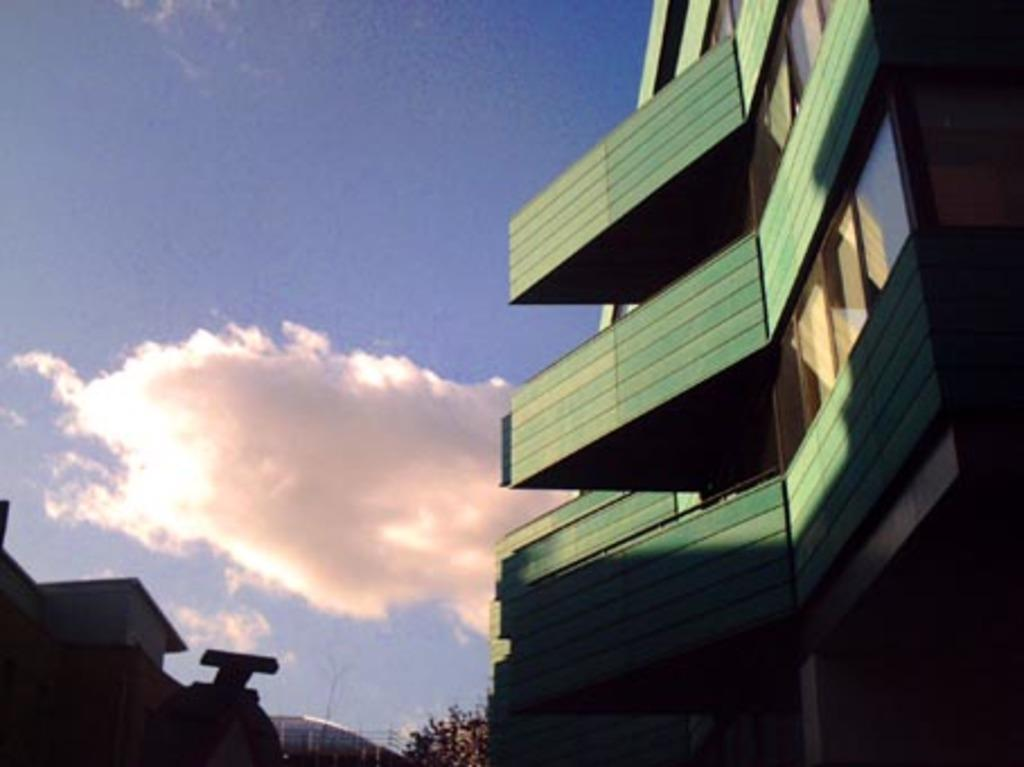What type of structures are present in the image? There are buildings in the image. What other natural elements can be seen in the image? There are trees in the image. What is visible at the top of the image? The sky is visible at the top of the image. What can be observed in the sky? There are clouds in the sky. How many steps does the boy take towards the beggar in the image? There is no boy or beggar present in the image. 